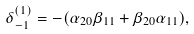<formula> <loc_0><loc_0><loc_500><loc_500>\delta _ { - 1 } ^ { ( 1 ) } = - ( \alpha _ { 2 0 } \beta _ { 1 1 } + \beta _ { 2 0 } \alpha _ { 1 1 } ) ,</formula> 